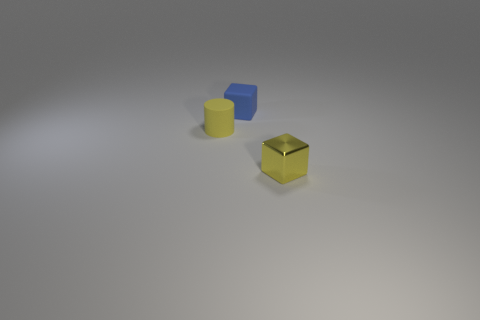Is the material of the tiny yellow block the same as the yellow thing that is left of the yellow block?
Your answer should be compact. No. What color is the cube behind the yellow thing that is right of the matte cylinder that is behind the metallic object?
Your answer should be very brief. Blue. What material is the yellow object that is the same size as the yellow cylinder?
Provide a succinct answer. Metal. What number of blue things have the same material as the yellow cube?
Make the answer very short. 0. There is a object on the left side of the tiny blue matte block; is its size the same as the object that is to the right of the rubber block?
Make the answer very short. Yes. What color is the tiny block that is behind the metallic thing?
Give a very brief answer. Blue. What material is the other thing that is the same color as the small metal object?
Ensure brevity in your answer.  Rubber. How many tiny shiny objects are the same color as the rubber cylinder?
Provide a short and direct response. 1. Do the metallic thing and the object that is left of the small blue matte block have the same size?
Offer a terse response. Yes. What size is the block in front of the tiny cube that is behind the cylinder on the left side of the tiny yellow shiny block?
Keep it short and to the point. Small. 